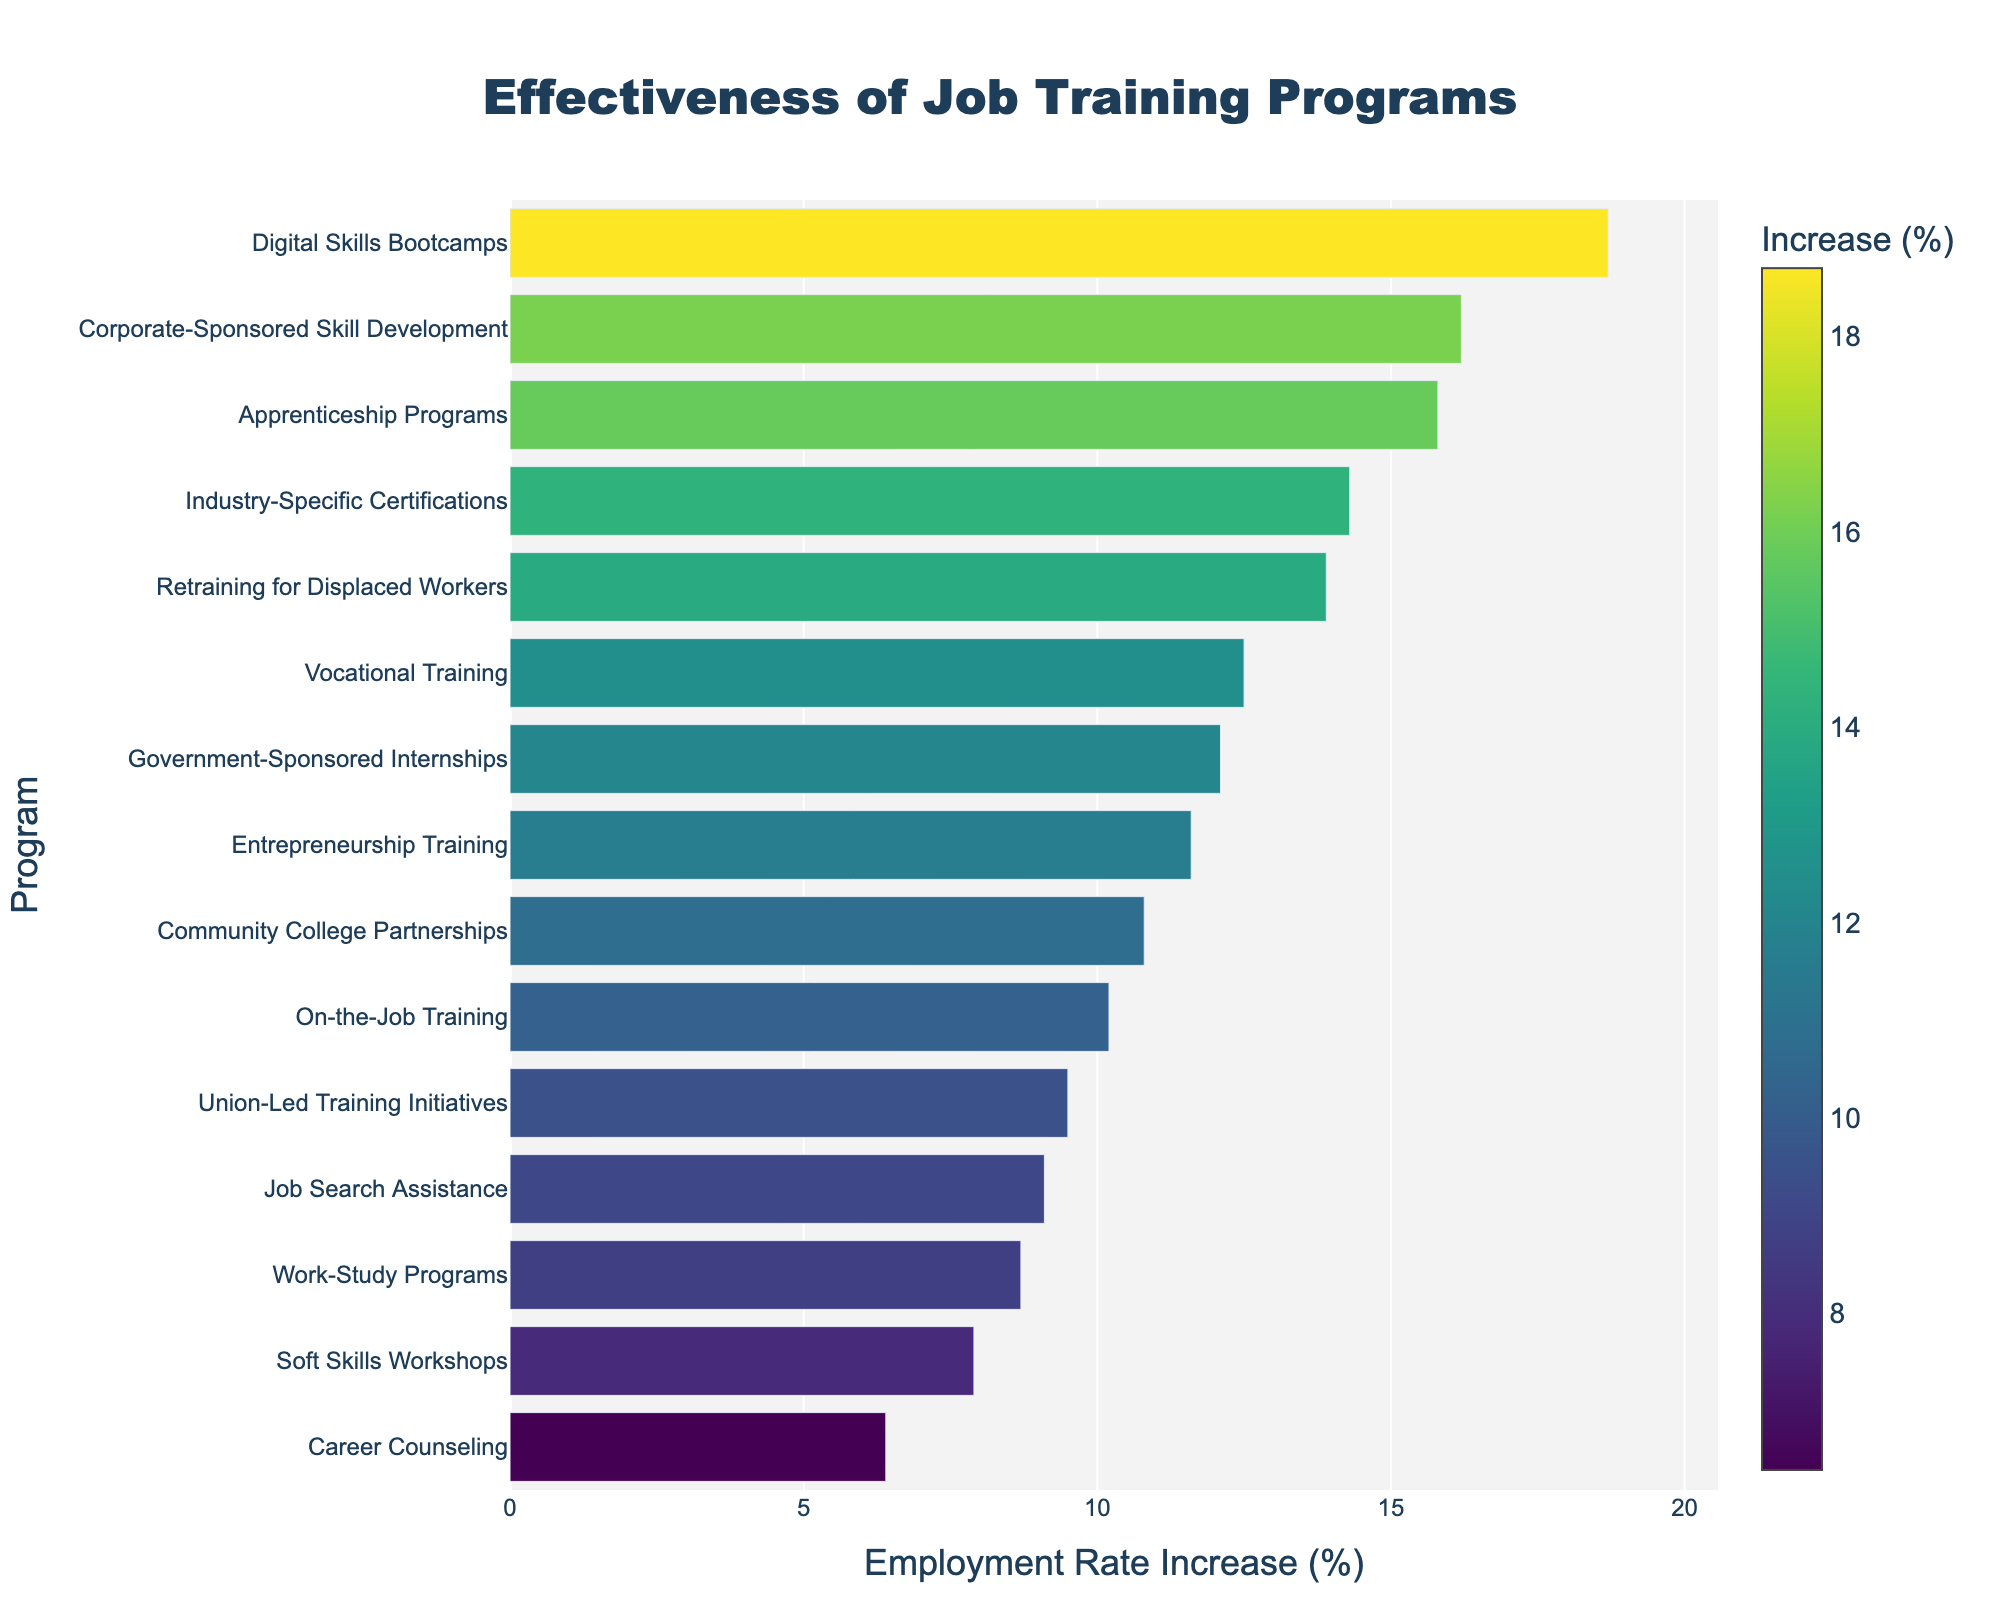What is the most effective job training program in terms of employment rate increase? The figure shows the employment rate increase for each job training program. The program with the highest figure is the most effective. The "Digital Skills Bootcamps" has the highest increase.
Answer: Digital Skills Bootcamps Which program has a higher employment rate increase: On-the-Job Training or Union-Led Training Initiatives? By comparing the bars for "On-the-Job Training" and "Union-Led Training Initiatives," we see that "On-the-Job Training" has a higher employment rate increase (10.2%) compared to "Union-Led Training Initiatives" (9.5%).
Answer: On-the-Job Training What is the average employment rate increase of the top three programs? Identify the top three programs: Digital Skills Bootcamps (18.7%), Corporate-Sponsored Skill Development (16.2%), and Apprenticeship Programs (15.8%). Calculate the average: (18.7 + 16.2 + 15.8) / 3 = 16.9.
Answer: 16.9% What is the total employment rate increase for programs with an increase below 10%? Identify programs with an increase below 10%: Soft Skills Workshops (7.9%), Career Counseling (6.4%), Job Search Assistance (9.1%), Work-Study Programs (8.7%), and Union-Led Training Initiatives (9.5%). Sum the increases: 7.9 + 6.4 + 9.1 + 8.7 + 9.5 = 41.6.
Answer: 41.6% Which has a larger employment rate increase: Government-Sponsored Internships or Community College Partnerships? Compare the bars for "Government-Sponsored Internships" (12.1%) and "Community College Partnerships" (10.8%). "Government-Sponsored Internships" has a higher value.
Answer: Government-Sponsored Internships How much higher is the employment rate increase for Corporate-Sponsored Skill Development compared to Career Counseling? Subtract the employment rate increase of Career Counseling (6.4%) from that of Corporate-Sponsored Skill Development (16.2%): 16.2 - 6.4 = 9.8.
Answer: 9.8% Are there more programs with employment rate increases below or above 10%? Count the programs below and above 10%. Below 10%: 6 (Soft Skills Workshops, Career Counseling, Job Search Assistance, Work-Study Programs, Union-Led Training Initiatives). Above 10%: 9 (remaining programs).
Answer: More programs above 10% What is the median employment rate increase for the programs listed? Arrange the employment rate increases in ascending order and find the middle value: 6.4, 7.9, 8.7, 9.1, 9.5, 10.2, 10.8, 11.6, 12.1, 12.5, 13.9, 14.3, 15.8, 16.2, 18.7. The median, being the 8th value in this ordered list, is 11.6.
Answer: 11.6% What is the difference in employment rate increase between the least and most effective programs? Subtract the employment rate increase of the least effective program, Career Counseling (6.4%), from the most effective program, Digital Skills Bootcamps (18.7%): 18.7 - 6.4 = 12.3.
Answer: 12.3% Which program with above 10% increase is the closest to having exactly a 10% increase in employment rate? Identify programs with above 10% increase and check which is closest to 10%. "On-the-Job Training" has 10.2% and is the closest.
Answer: On-the-Job Training 